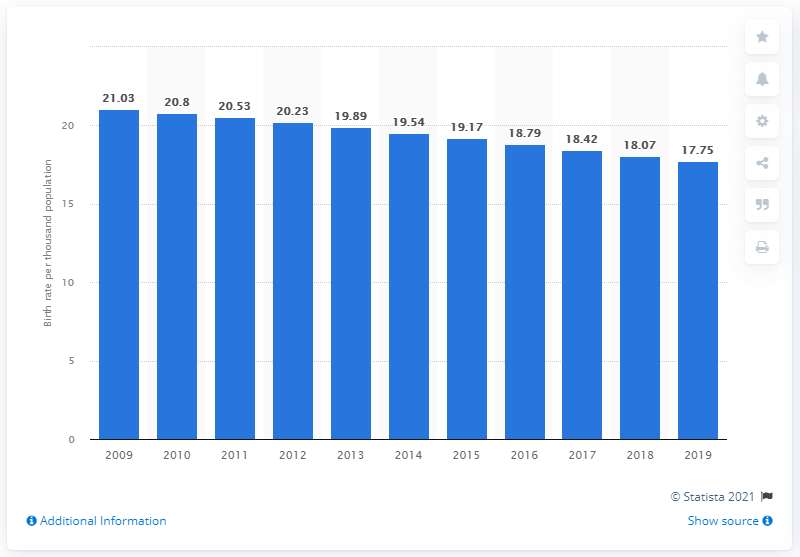Specify some key components in this picture. In 2019, the crude birth rate in Indonesia was 17.75. 